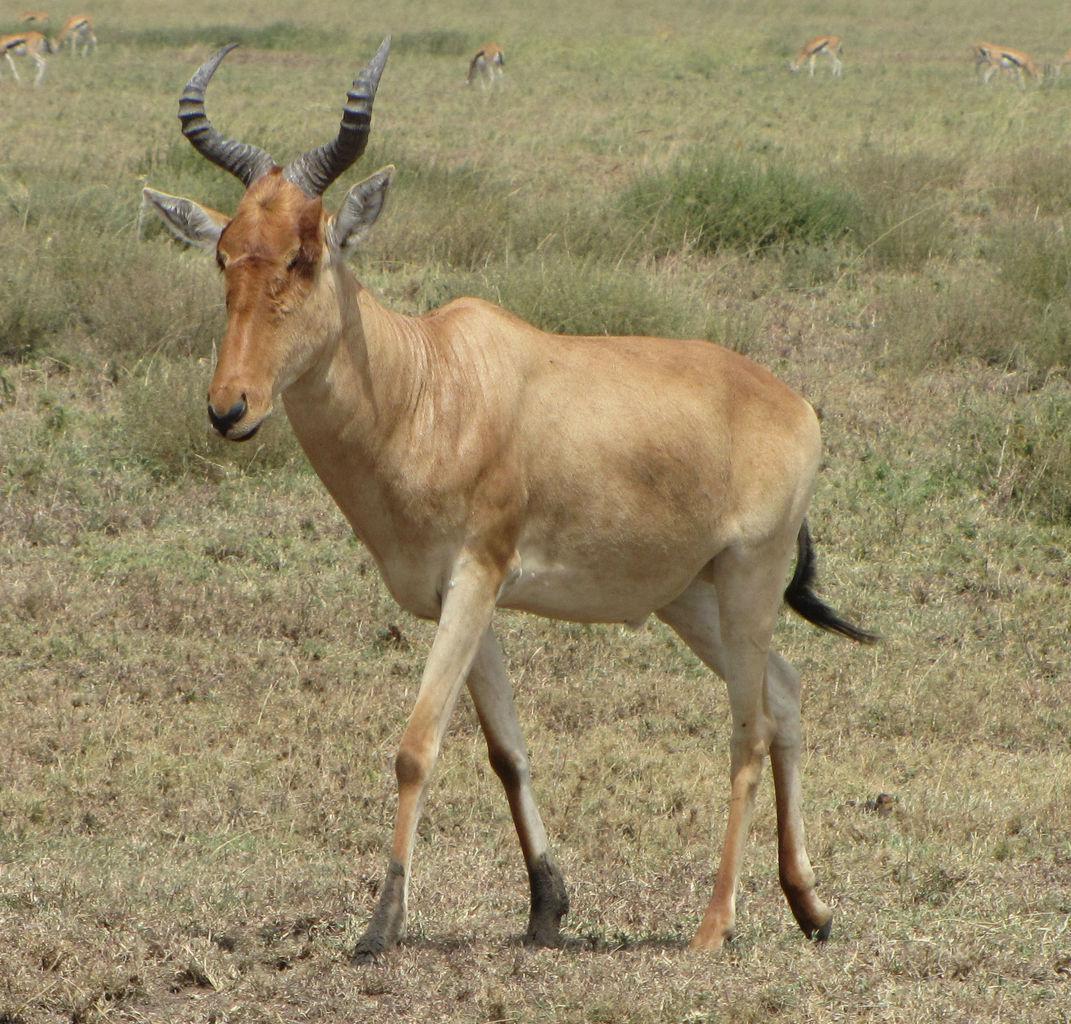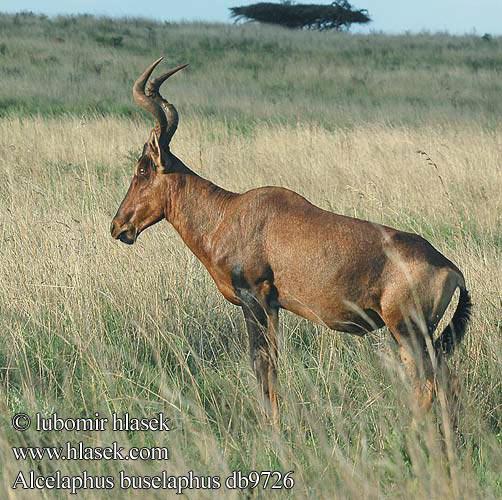The first image is the image on the left, the second image is the image on the right. For the images shown, is this caption "There are more animals in the image on the right than on the left." true? Answer yes or no. No. The first image is the image on the left, the second image is the image on the right. For the images displayed, is the sentence "The right image shows more than one antelope-type animal." factually correct? Answer yes or no. No. 